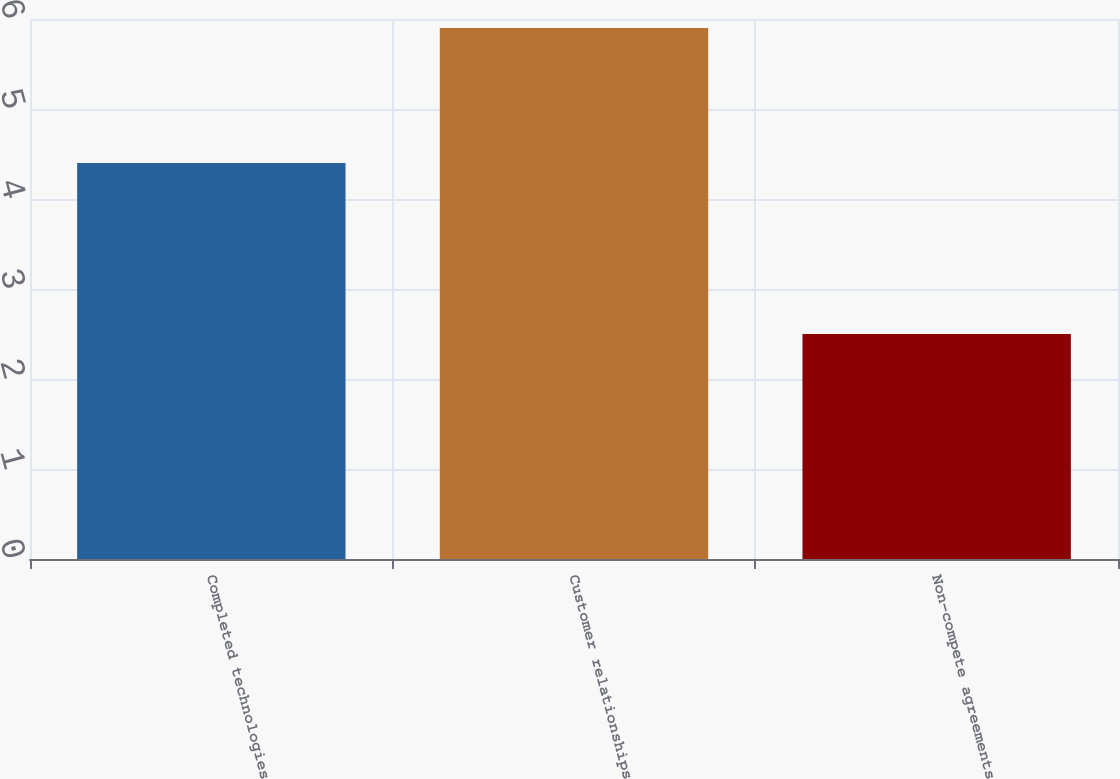Convert chart to OTSL. <chart><loc_0><loc_0><loc_500><loc_500><bar_chart><fcel>Completed technologies<fcel>Customer relationships<fcel>Non-compete agreements<nl><fcel>4.4<fcel>5.9<fcel>2.5<nl></chart> 